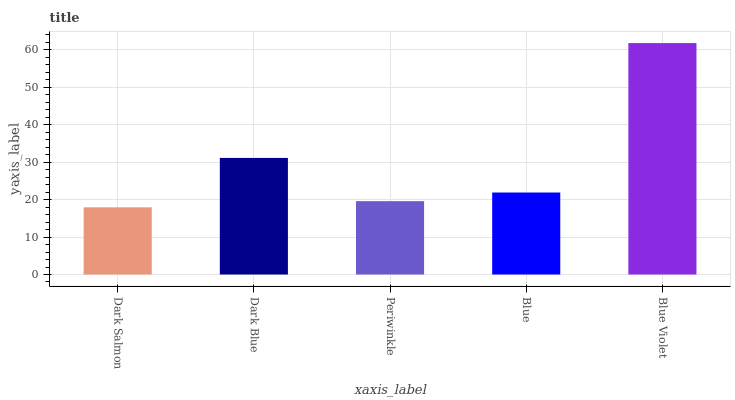Is Dark Salmon the minimum?
Answer yes or no. Yes. Is Blue Violet the maximum?
Answer yes or no. Yes. Is Dark Blue the minimum?
Answer yes or no. No. Is Dark Blue the maximum?
Answer yes or no. No. Is Dark Blue greater than Dark Salmon?
Answer yes or no. Yes. Is Dark Salmon less than Dark Blue?
Answer yes or no. Yes. Is Dark Salmon greater than Dark Blue?
Answer yes or no. No. Is Dark Blue less than Dark Salmon?
Answer yes or no. No. Is Blue the high median?
Answer yes or no. Yes. Is Blue the low median?
Answer yes or no. Yes. Is Periwinkle the high median?
Answer yes or no. No. Is Blue Violet the low median?
Answer yes or no. No. 